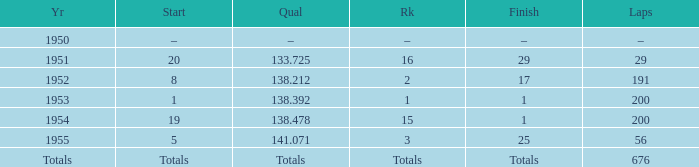How many laps was qualifier of 138.212? 191.0. 